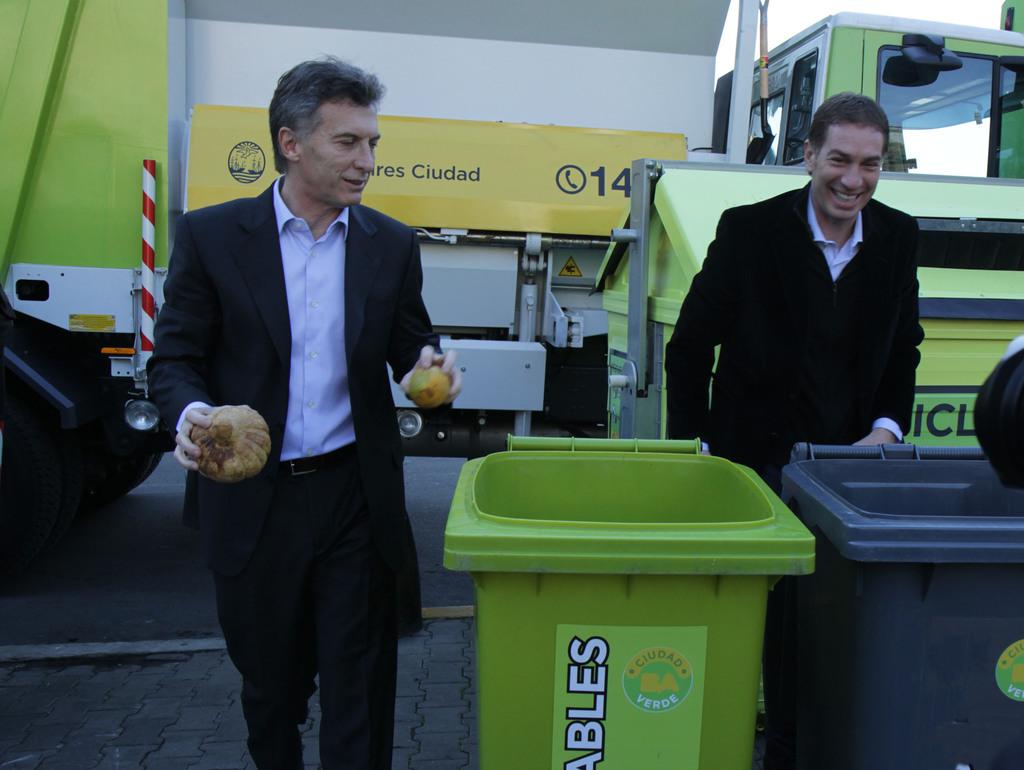What number is visible on the truck?
Offer a terse response. 14. What does the green trash can say?
Provide a short and direct response. Unanswerable. 